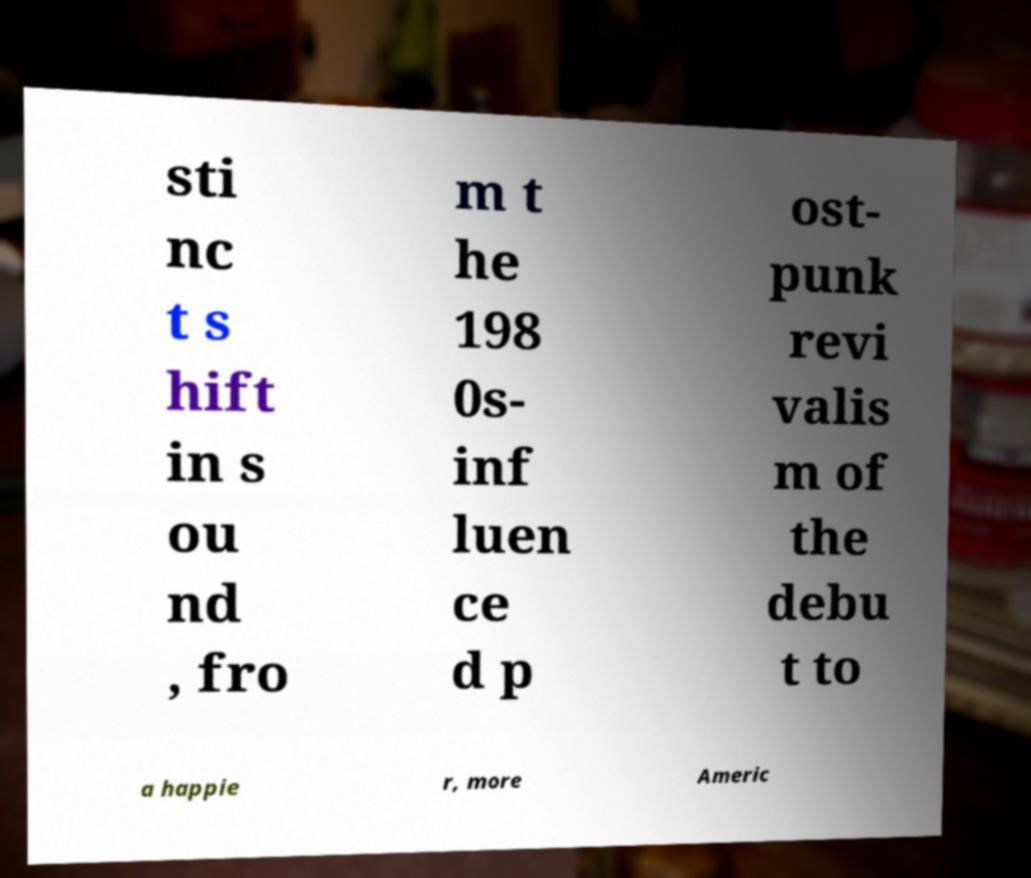What messages or text are displayed in this image? I need them in a readable, typed format. sti nc t s hift in s ou nd , fro m t he 198 0s- inf luen ce d p ost- punk revi valis m of the debu t to a happie r, more Americ 